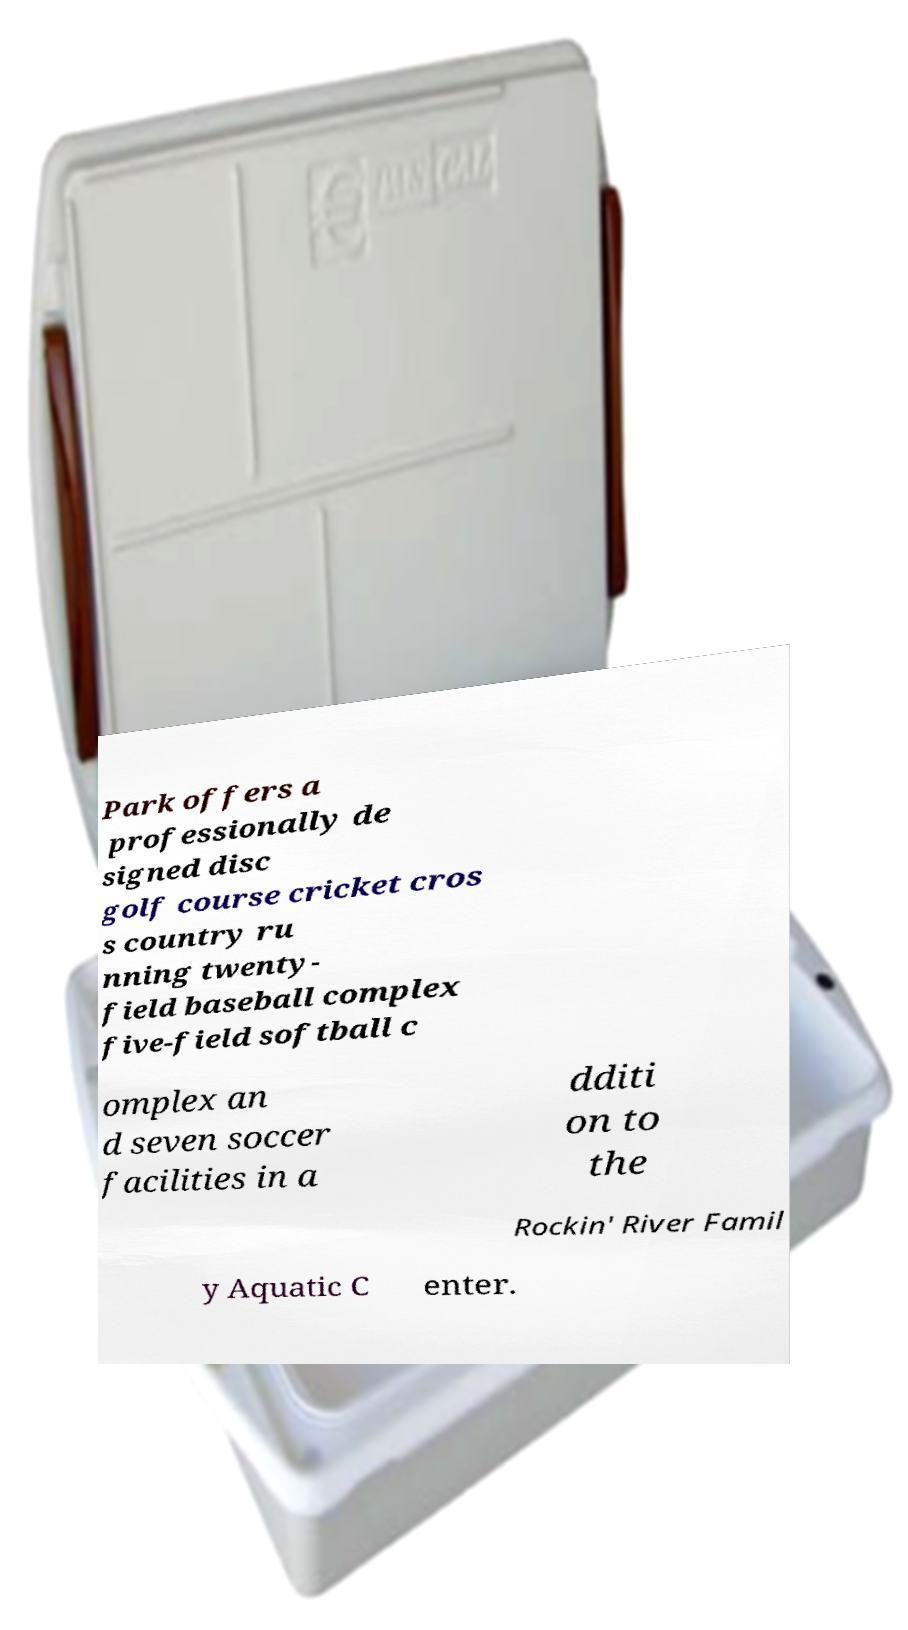For documentation purposes, I need the text within this image transcribed. Could you provide that? Park offers a professionally de signed disc golf course cricket cros s country ru nning twenty- field baseball complex five-field softball c omplex an d seven soccer facilities in a dditi on to the Rockin' River Famil y Aquatic C enter. 